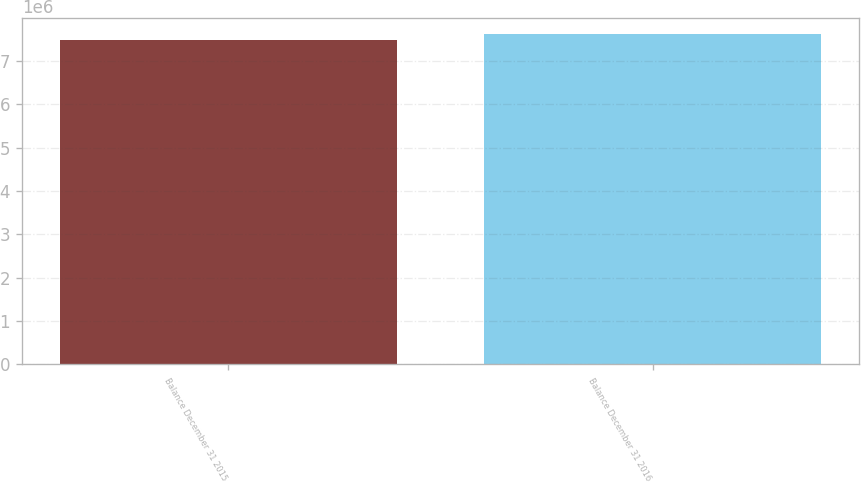<chart> <loc_0><loc_0><loc_500><loc_500><bar_chart><fcel>Balance December 31 2015<fcel>Balance December 31 2016<nl><fcel>7.47608e+06<fcel>7.6185e+06<nl></chart> 